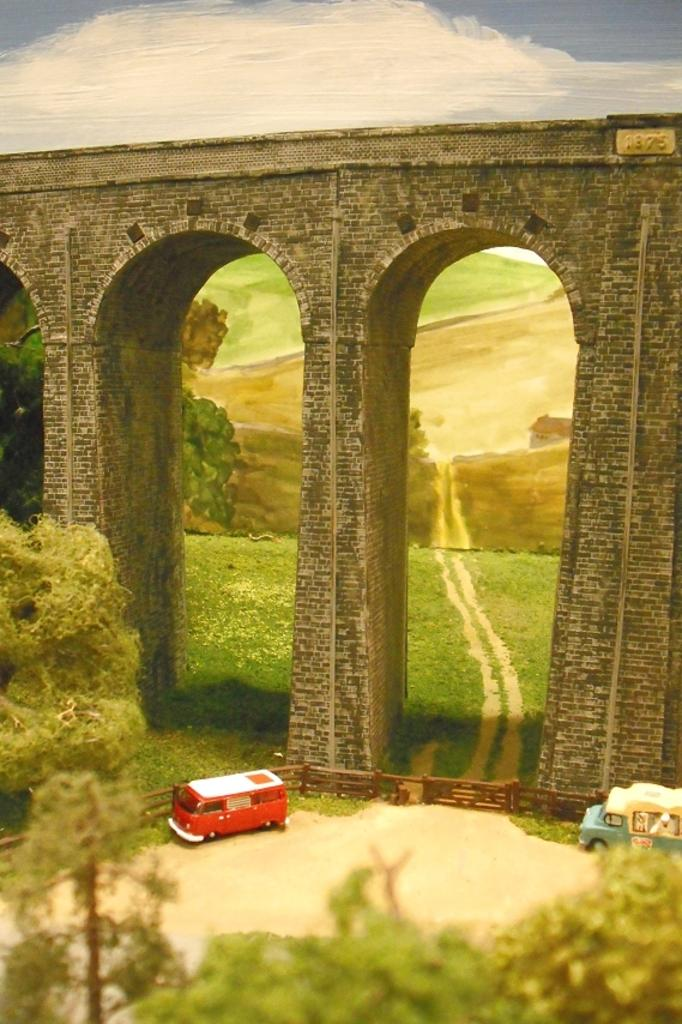What types of objects can be seen in the image? There are vehicles in the image. What natural elements are present in the image? Trees are present at the bottom and middle of the image. What man-made structure is visible in the image? There is a bridge in the middle of the image. What part of the natural environment is visible in the image? The sky is visible in the background of the image. What type of dust can be seen on the daughter's face in the image? There is no daughter present in the image, and therefore no dust on her face. How many parents are visible in the image? There are no parents present in the image. 